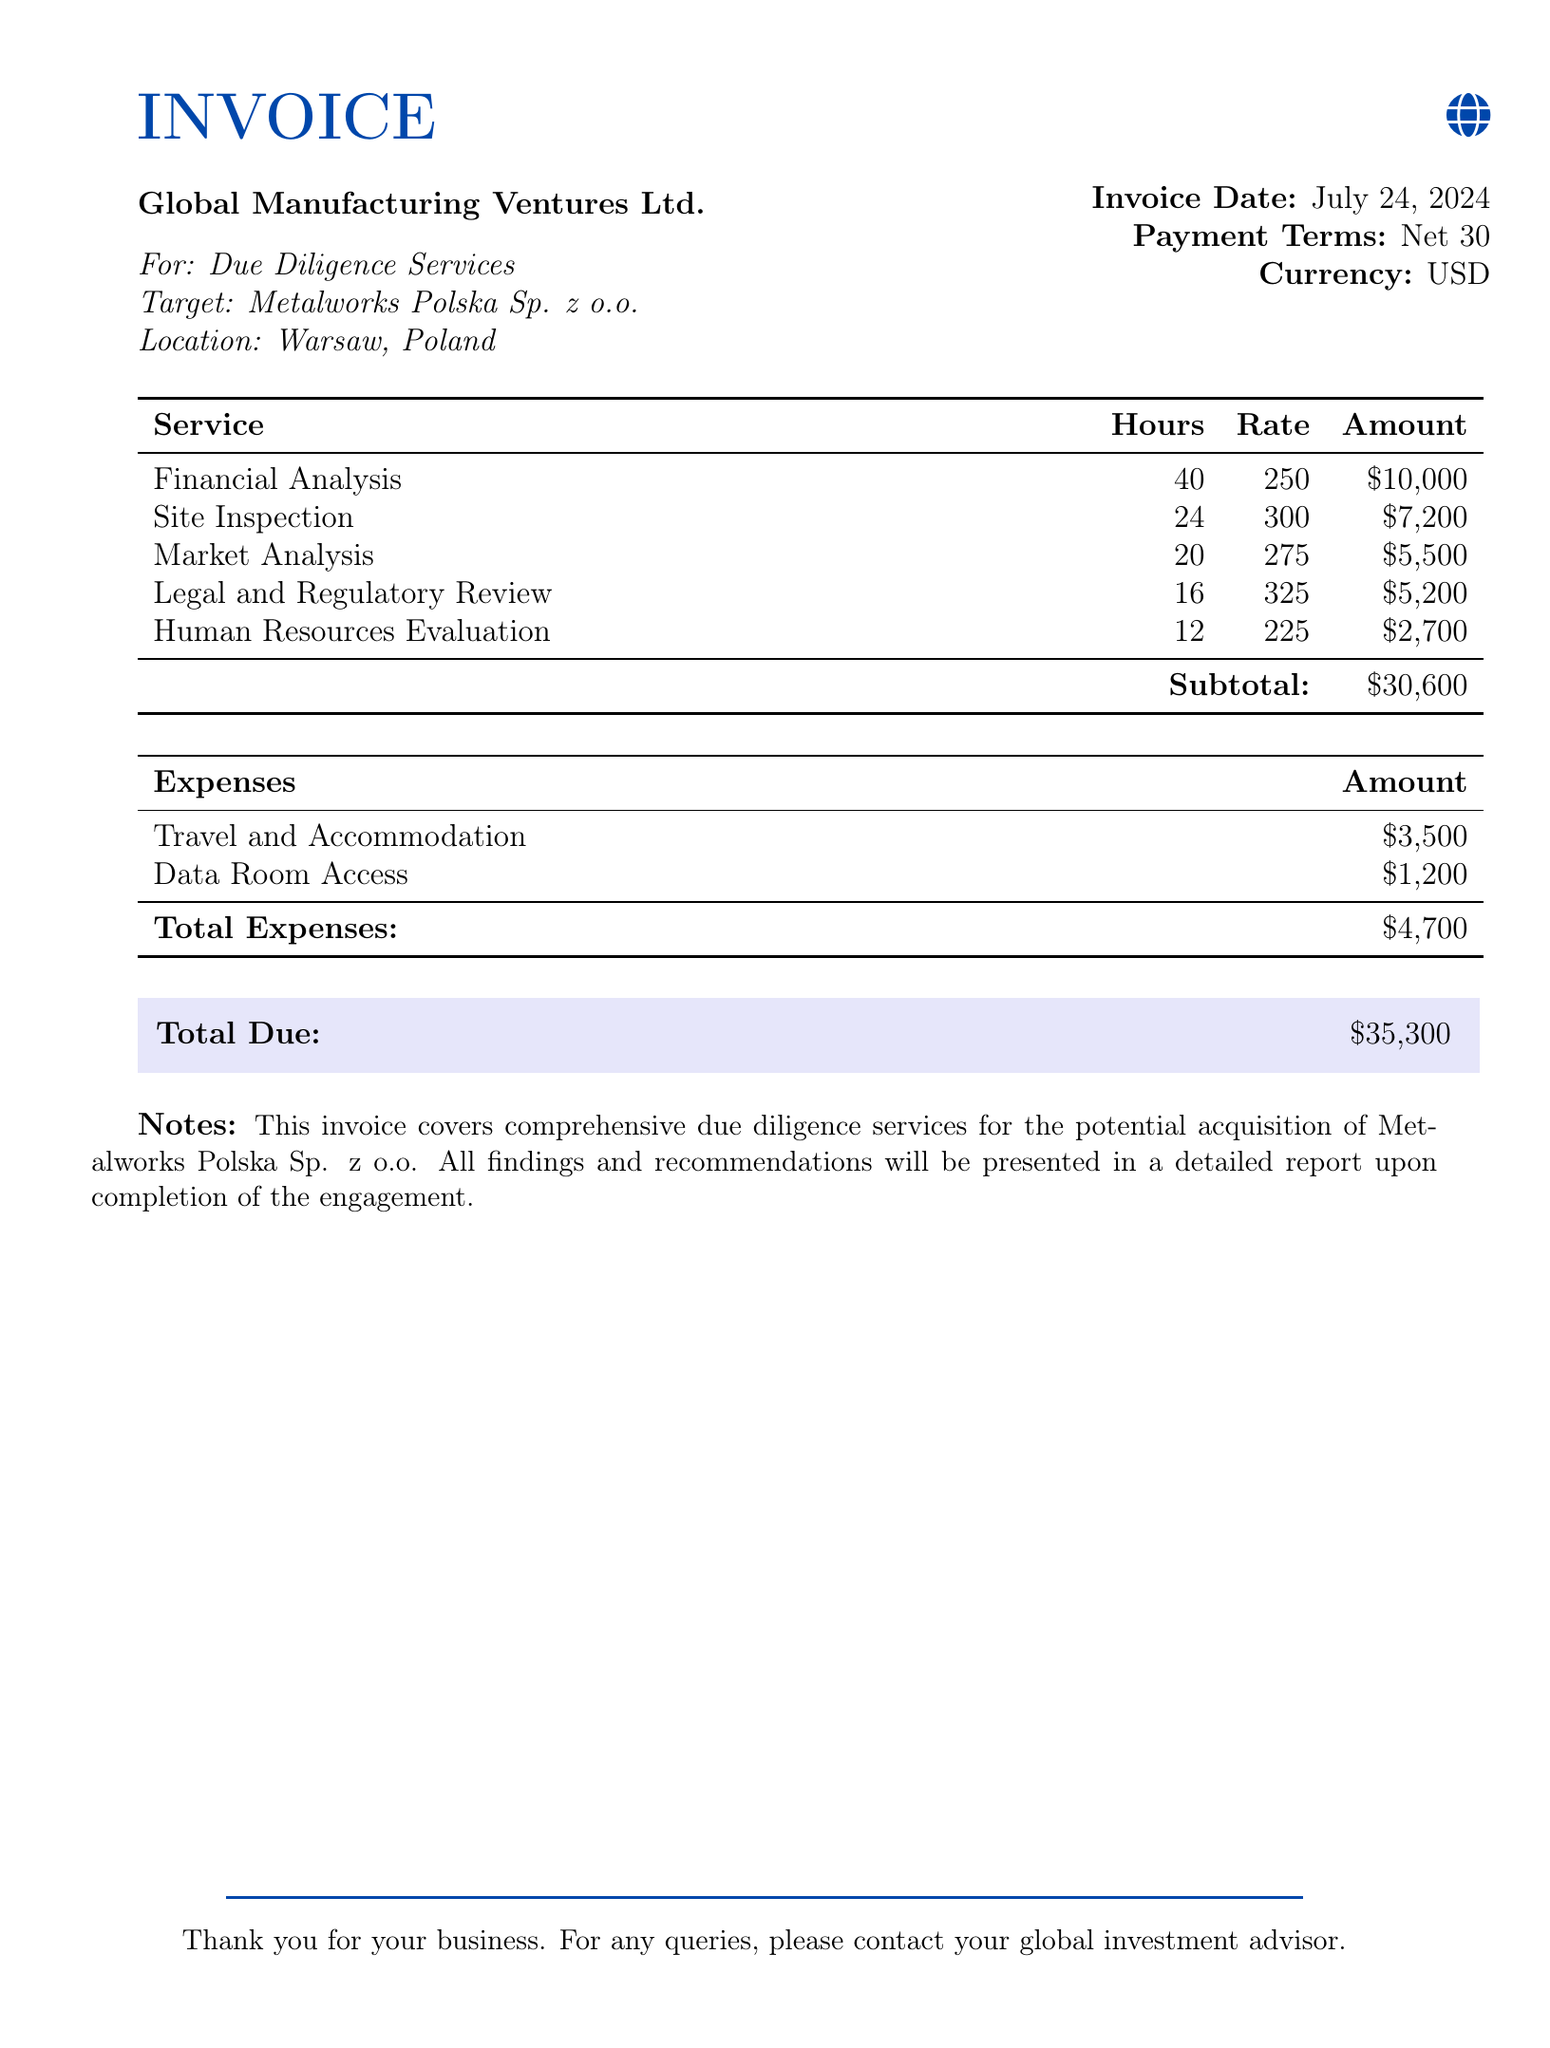What is the invoice date? The invoice date is specified in the document as the date of issuance, which is today.
Answer: today What is the total due amount? The total due amount is prominently displayed in the document, highlighting the final amount owed.
Answer: $35,300 How many hours were allocated for financial analysis? The document indicates the number of hours worked for financial analysis services.
Answer: 40 What is the payment term specified in the invoice? The payment term refers to the time allowed for payment after the invoice date, as mentioned in the document.
Answer: Net 30 What location is the target company based in? The target company's location is mentioned in the document as part of the due diligence services.
Answer: Warsaw, Poland How much was spent on travel and accommodation? The document provides a breakdown of expenses, including the specific amount for travel and accommodation.
Answer: $3,500 Which service had the highest hourly rate? The document lists the different services along with their respective hourly rates, allowing for comparison.
Answer: Site Inspection How many hours were spent on the legal and regulatory review? The document specifies the number of hours dedicated to the legal and regulatory review service.
Answer: 16 What type of services does this invoice cover? The document indicates that the services are related to due diligence in a potential acquisition.
Answer: Due Diligence Services 